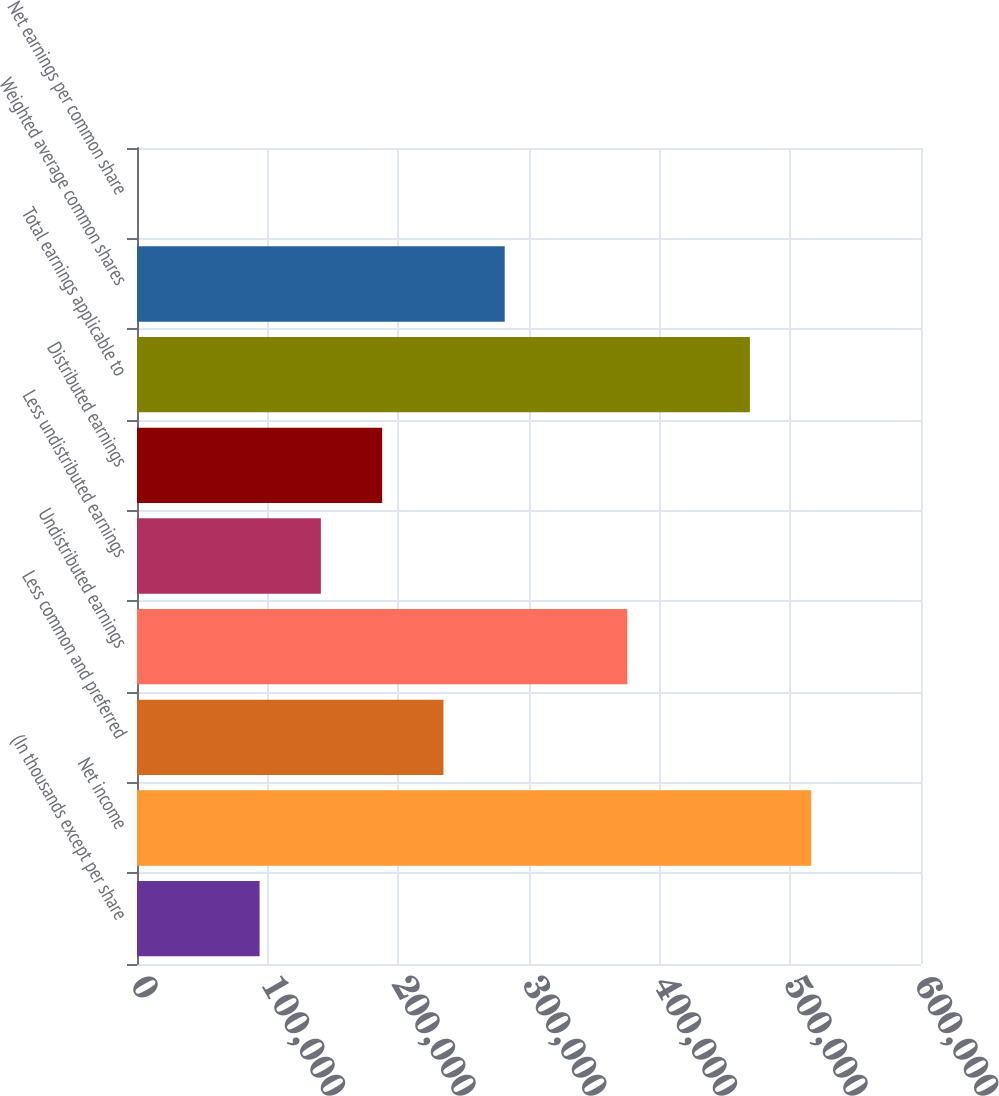<chart> <loc_0><loc_0><loc_500><loc_500><bar_chart><fcel>(In thousands except per share<fcel>Net income<fcel>Less common and preferred<fcel>Undistributed earnings<fcel>Less undistributed earnings<fcel>Distributed earnings<fcel>Total earnings applicable to<fcel>Weighted average common shares<fcel>Net earnings per common share<nl><fcel>93811.6<fcel>515955<fcel>234526<fcel>375240<fcel>140716<fcel>187621<fcel>469050<fcel>281431<fcel>2<nl></chart> 